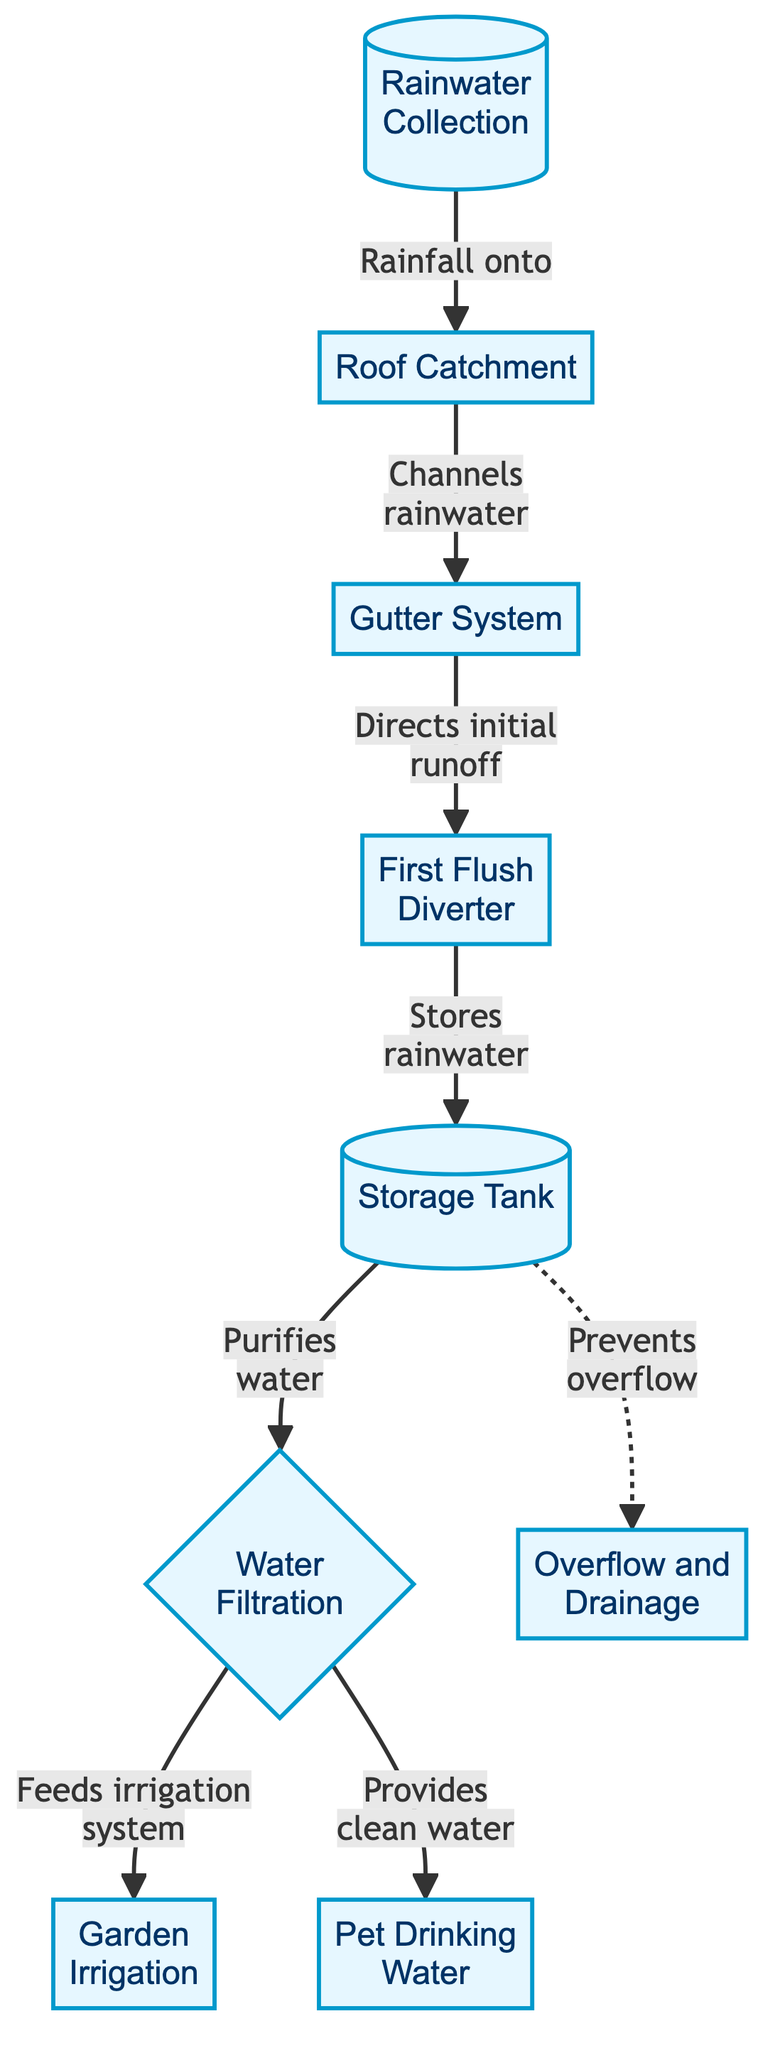What is the first step in the rainwater harvesting system? The first step in the system is represented as "Rainwater Collection" in the diagram, which indicates that the process begins with collecting rainwater.
Answer: Rainwater Collection Which component channels rainwater from the roof? The component that channels rainwater from the roof is the "Gutter System," as depicted in the diagram.
Answer: Gutter System How many steps are there in the rainwater harvesting process? The diagram shows a total of 9 steps or components in the rainwater harvesting process.
Answer: 9 What does the first flush diverter do? The "First Flush Diverter" manages the initial runoff, which is essential to prevent contamination in stored rainwater.
Answer: Directs initial runoff Which two systems utilize purified water? The two systems that utilize purified water are "Garden Irrigation" and "Pet Drinking Water," as clearly stated in the diagram.
Answer: Garden Irrigation and Pet Drinking Water What is the purpose of the storage tank? The storage tank's purpose is to store rainwater, which is crucial for the subsequent processes in the diagram.
Answer: Stores rainwater What happens to the water after filtration? After filtration, the purified water "feeds irrigation system" and "provides clean water" for pets, highlighting its dual function.
Answer: Feeds irrigation system and Provides clean water Which component prevents overflow? The "Overflow and Drainage" component is indicated in the diagram as the mechanism that prevents overflow from the storage tank.
Answer: Overflow and Drainage How is the water initially collected? The water is initially collected through "Rainfall onto Roof Catchment," which indicates the start of the rainwater collection process.
Answer: Rainfall onto Roof Catchment What connects the storage tank to garden irrigation? The connection between the "Storage Tank" and "Garden Irrigation" is established through the "Water Filtration" process, turning collected water into usable form.
Answer: Water Filtration 